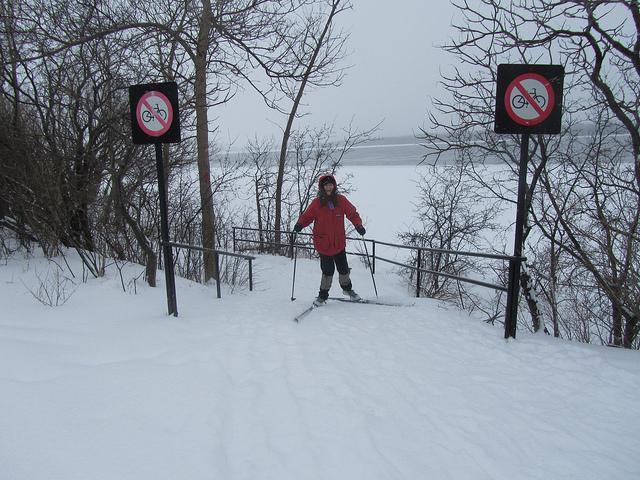How many zebras are in this picture?
Give a very brief answer. 0. 